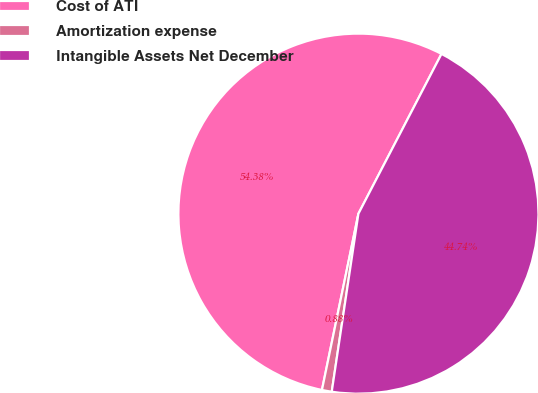<chart> <loc_0><loc_0><loc_500><loc_500><pie_chart><fcel>Cost of ATI<fcel>Amortization expense<fcel>Intangible Assets Net December<nl><fcel>54.39%<fcel>0.88%<fcel>44.74%<nl></chart> 